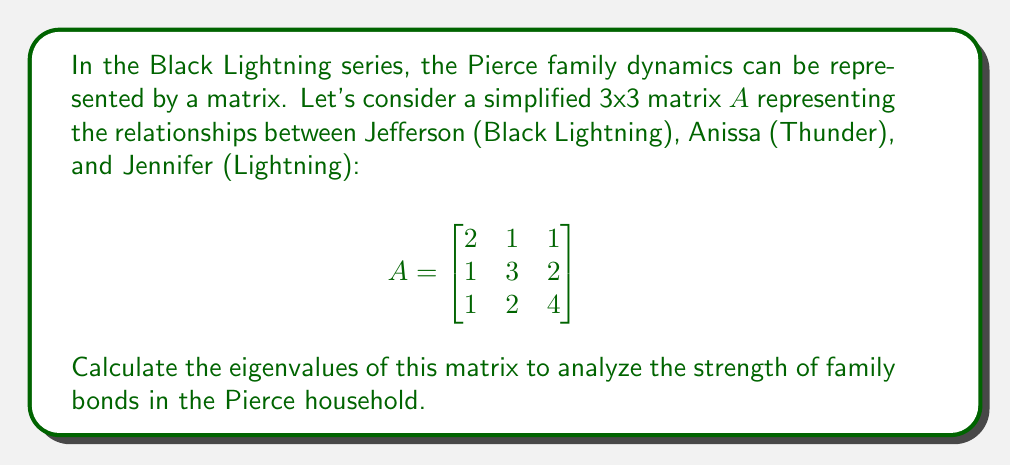Can you solve this math problem? To find the eigenvalues of matrix $A$, we need to solve the characteristic equation:

1) First, we set up the equation $\det(A - \lambda I) = 0$, where $I$ is the 3x3 identity matrix:

   $$\det\begin{pmatrix}
   2-\lambda & 1 & 1 \\
   1 & 3-\lambda & 2 \\
   1 & 2 & 4-\lambda
   \end{pmatrix} = 0$$

2) Expand the determinant:
   $$(2-\lambda)[(3-\lambda)(4-\lambda)-4] - 1[(1)(4-\lambda)-2] + 1[1(2)-1(3-\lambda)] = 0$$

3) Simplify:
   $$(2-\lambda)[(12-7\lambda+\lambda^2)-4] - [(4-\lambda)-2] + [2-(3-\lambda)] = 0$$
   $$(2-\lambda)(8-7\lambda+\lambda^2) - (2-\lambda) + (\lambda-1) = 0$$

4) Expand:
   $$16-14\lambda+2\lambda^2-8\lambda+7\lambda^2-\lambda^3-2+\lambda+\lambda-1 = 0$$

5) Collect terms:
   $$-\lambda^3+9\lambda^2-15\lambda+13 = 0$$

6) This is a cubic equation. We can factor out $(\lambda-1)$:
   $$(\lambda-1)(-\lambda^2+8\lambda-13) = 0$$

7) Using the quadratic formula for $-\lambda^2+8\lambda-13 = 0$:
   $$\lambda = \frac{-8 \pm \sqrt{64+52}}{-2} = \frac{-8 \pm \sqrt{116}}{-2} = 4 \pm \sqrt{29}$$

Therefore, the eigenvalues are:
$\lambda_1 = 1$, $\lambda_2 = 4 + \sqrt{29}$, and $\lambda_3 = 4 - \sqrt{29}$
Answer: $\lambda_1 = 1$, $\lambda_2 = 4 + \sqrt{29}$, $\lambda_3 = 4 - \sqrt{29}$ 